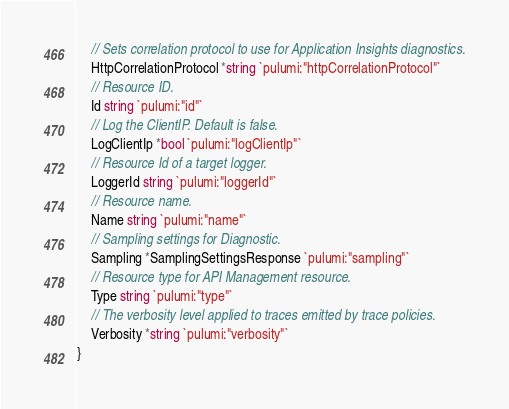Convert code to text. <code><loc_0><loc_0><loc_500><loc_500><_Go_>	// Sets correlation protocol to use for Application Insights diagnostics.
	HttpCorrelationProtocol *string `pulumi:"httpCorrelationProtocol"`
	// Resource ID.
	Id string `pulumi:"id"`
	// Log the ClientIP. Default is false.
	LogClientIp *bool `pulumi:"logClientIp"`
	// Resource Id of a target logger.
	LoggerId string `pulumi:"loggerId"`
	// Resource name.
	Name string `pulumi:"name"`
	// Sampling settings for Diagnostic.
	Sampling *SamplingSettingsResponse `pulumi:"sampling"`
	// Resource type for API Management resource.
	Type string `pulumi:"type"`
	// The verbosity level applied to traces emitted by trace policies.
	Verbosity *string `pulumi:"verbosity"`
}
</code> 